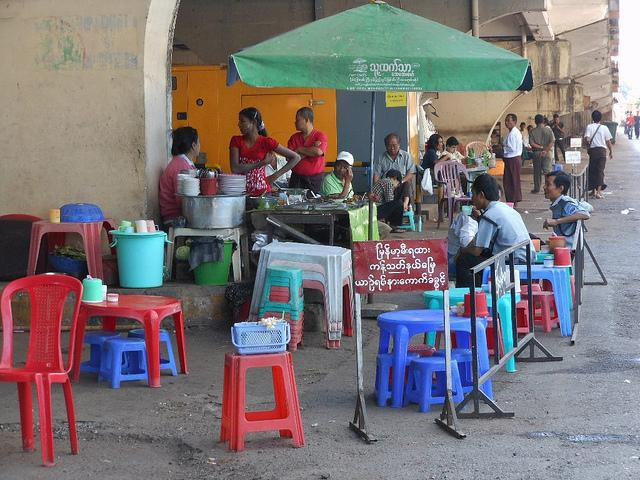What are the colored plastic objects for? Please explain your reasoning. sitting. This is an outdoor dining area that is informal and has plastic tables with chairs. 